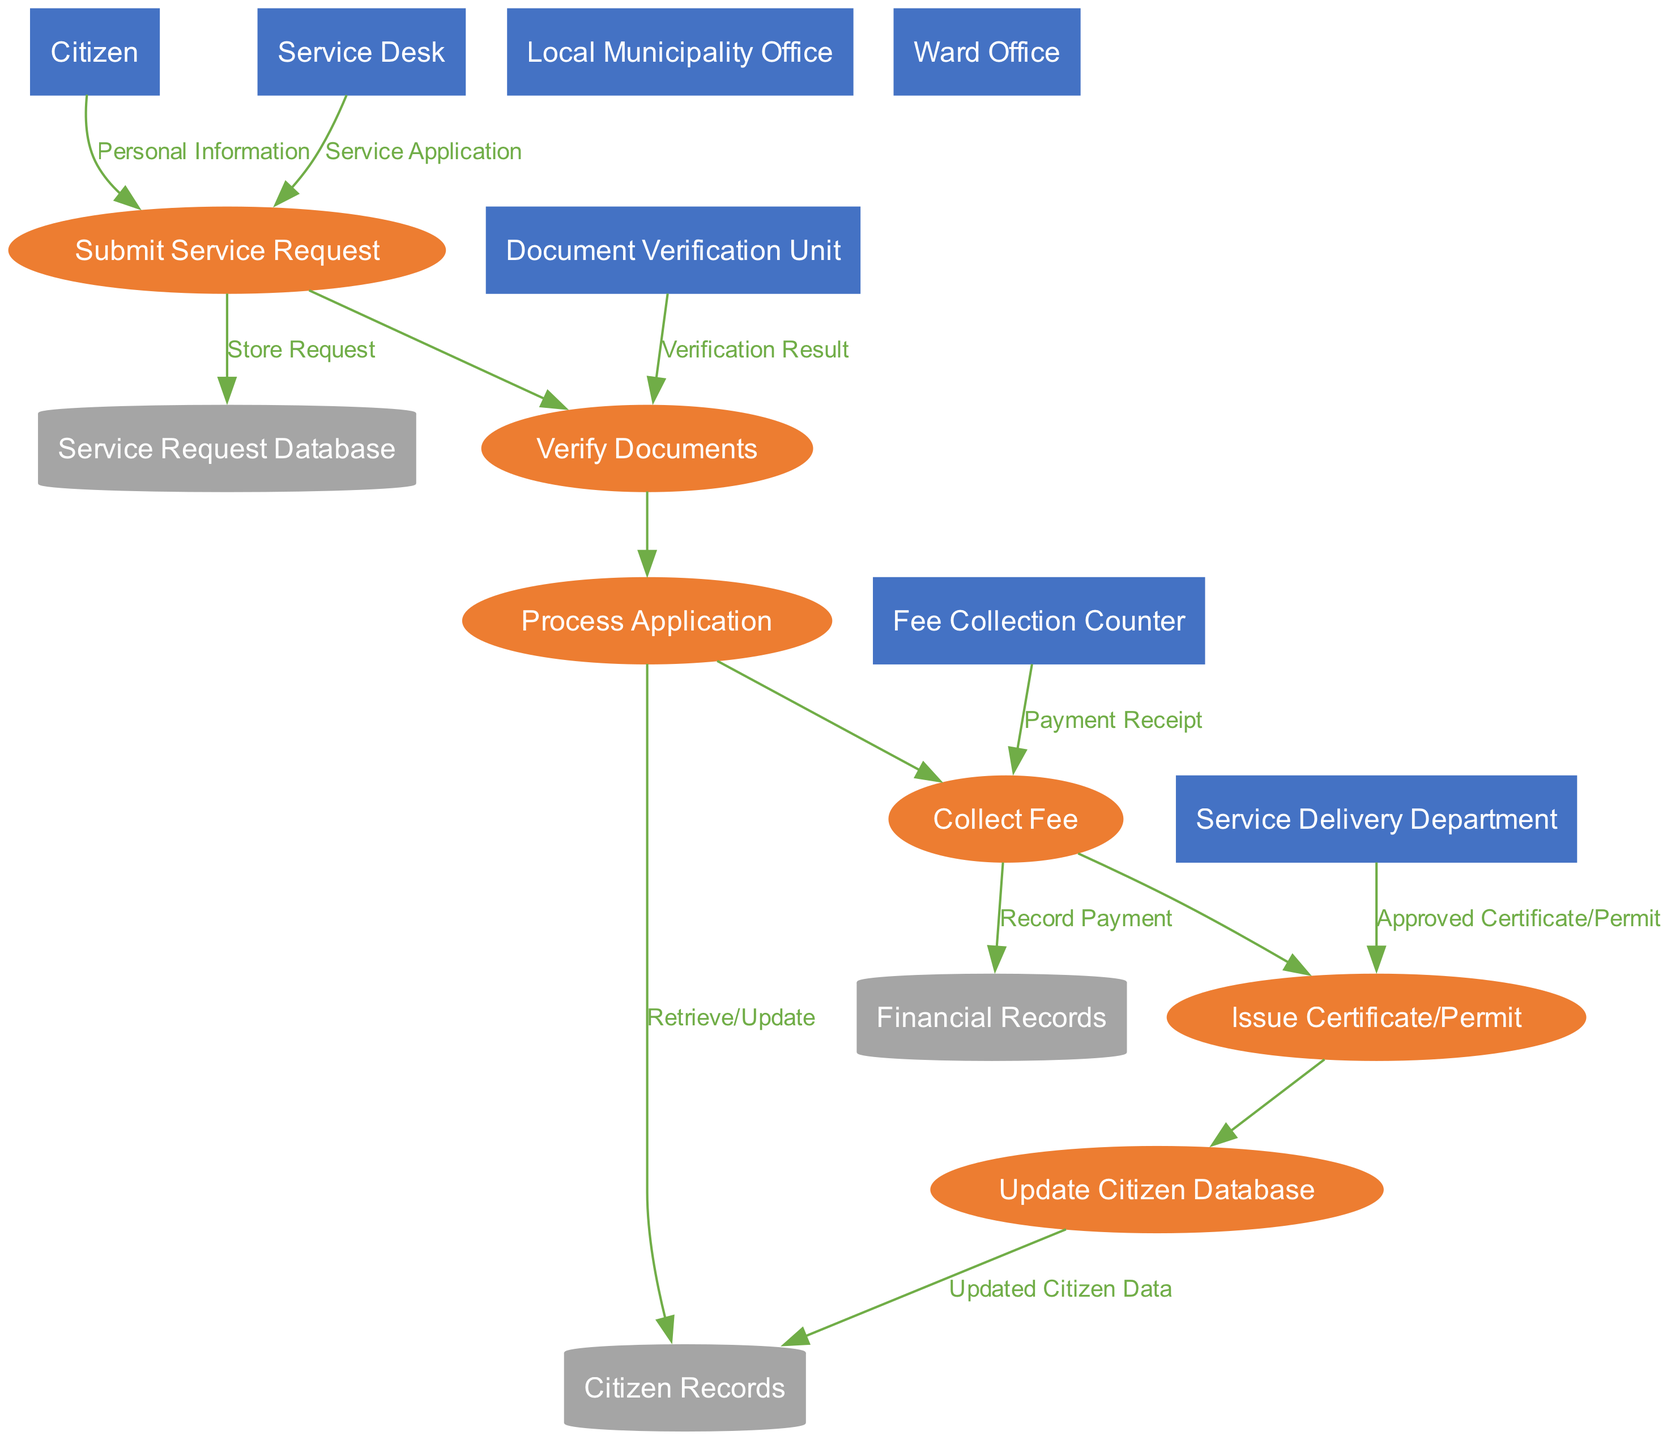What are the entities involved in this diagram? The diagram includes the following entities: Citizen, Local Municipality Office, Ward Office, Service Desk, Document Verification Unit, Fee Collection Counter, and Service Delivery Department.
Answer: Citizen, Local Municipality Office, Ward Office, Service Desk, Document Verification Unit, Fee Collection Counter, Service Delivery Department How many processes are depicted in the diagram? The diagram shows six processes: Submit Service Request, Verify Documents, Process Application, Collect Fee, Issue Certificate/Permit, and Update Citizen Database. The total number of processes is counted directly from their listing in the diagram.
Answer: Six Which entity submits the Service Request? In the diagram, the entity named Citizen is shown to submit the Service Request as indicated by the directed edge from Citizen to Submit Service Request.
Answer: Citizen What data flows from the Fee Collection Counter to the Collect Fee process? The data flow from the Fee Collection Counter to the Collect Fee process is labeled as Payment Receipt. This connects the process of collecting fees to the financial documentation involved.
Answer: Payment Receipt What is the final output of the diagram after all processes are completed? The final output of the diagram is the Approved Certificate/Permit, which is issued as the last step in the process flow. The edge from Issue Certificate/Permit indicates this output.
Answer: Approved Certificate/Permit Which data store receives updated information from the Update Citizen Database process? The Citizen Records data store receives updated information, as represented by the directed edge leading to Citizen Records after Update Citizen Database indicates the process of updating citizen data.
Answer: Citizen Records How many data stores are present in the diagram? The diagram includes three data stores: Citizen Records, Service Request Database, and Financial Records. The count of nodes representing these stores provides the total.
Answer: Three What is the relationship between the Verify Documents process and the Process Application process? The relationship between Verify Documents and Process Application is a direct flow, where the output of Verify Documents feeds into Process Application, indicating the sequence in the service delivery system.
Answer: Direct flow Which process is responsible for fee collection? The process responsible for fee collection is labeled Collect Fee, which is specifically indicated to receive the Payment Receipt data flow and involves financial transactions.
Answer: Collect Fee 